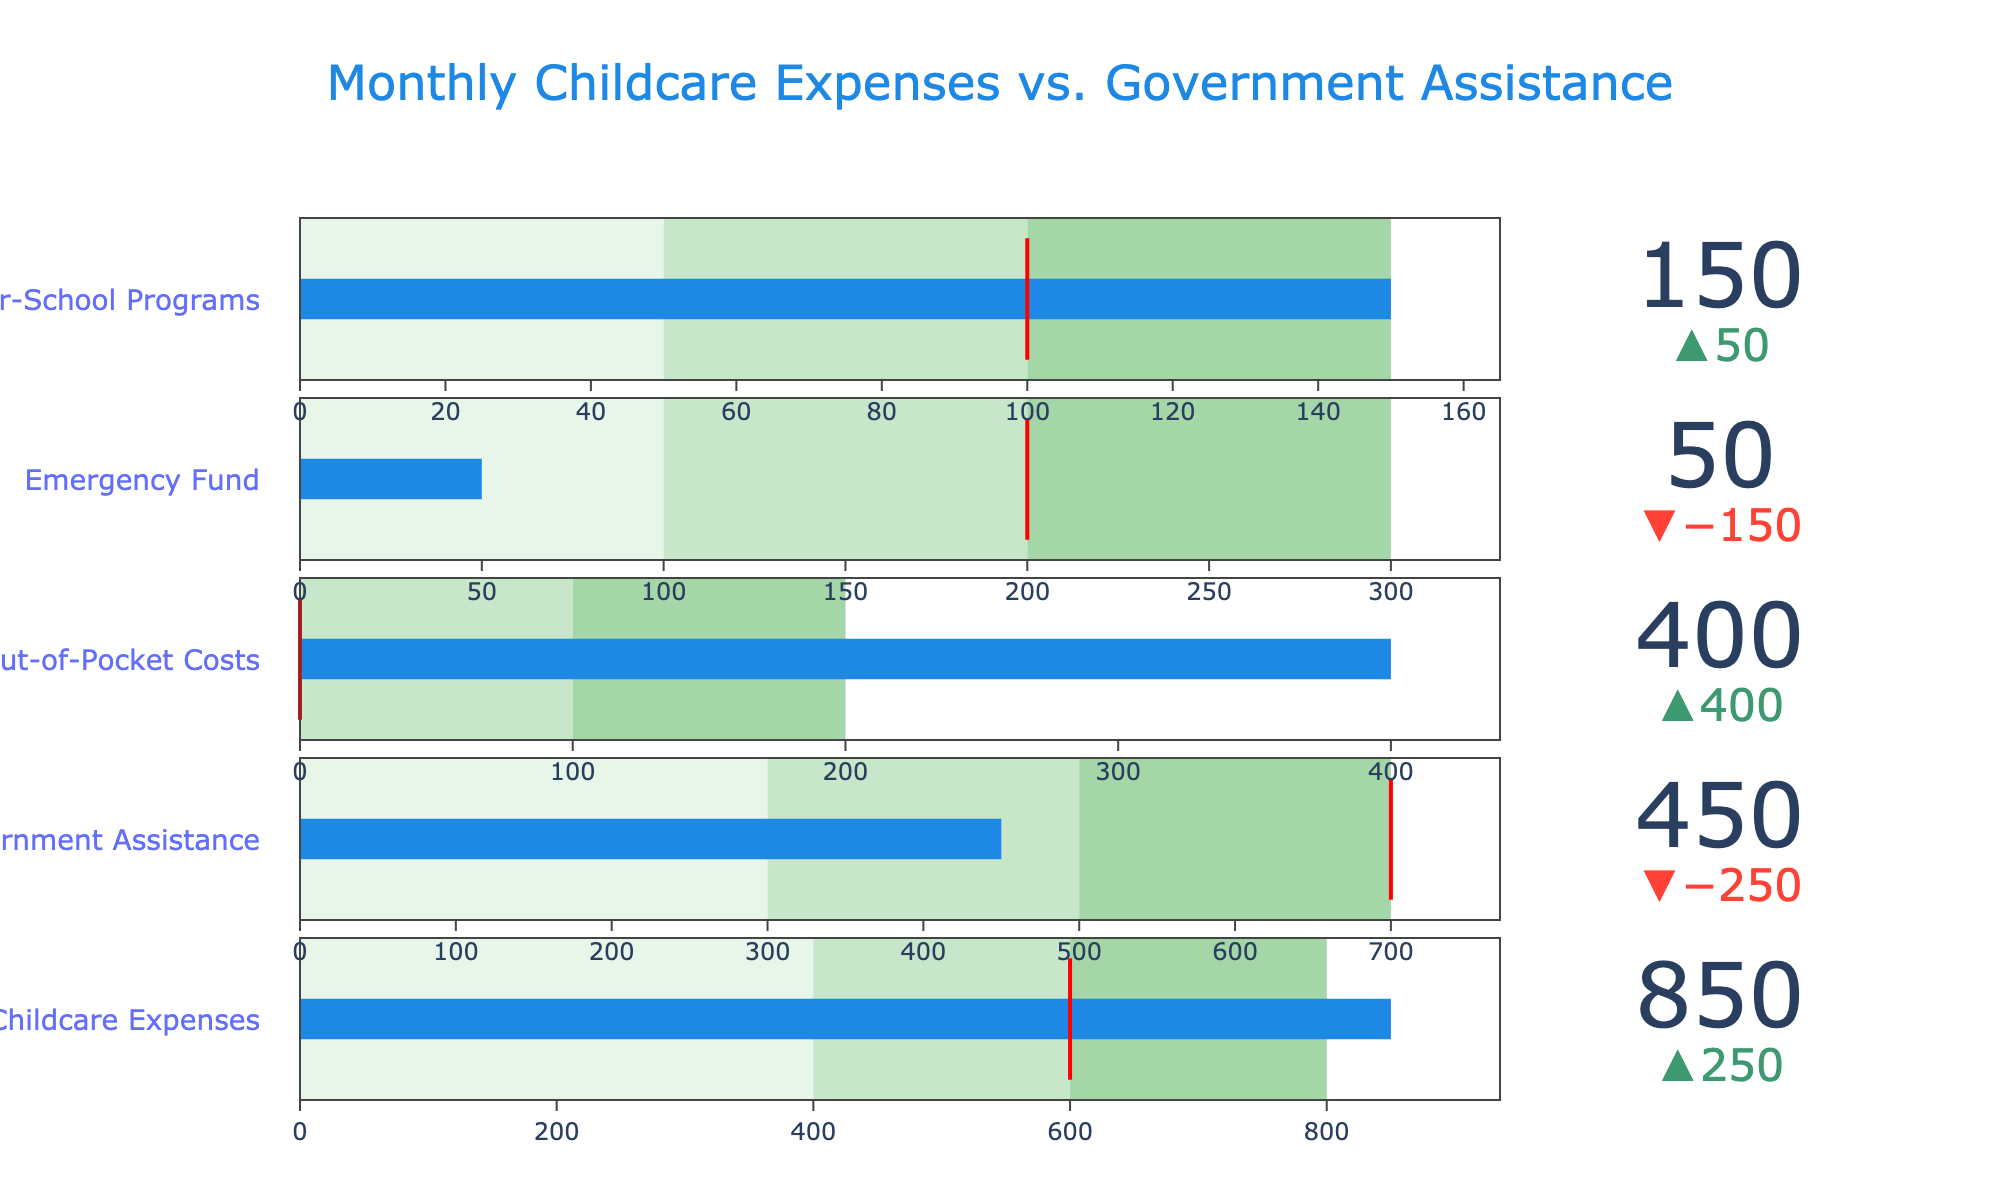What is the title of the figure? The title is prominently displayed at the top of the figure in a large font.
Answer: Monthly Childcare Expenses vs. Government Assistance How much are the actual monthly childcare expenses? The actual monthly childcare expenses value is marked in the bullet chart under the "Childcare Expenses" category.
Answer: 850 What is the target value for government assistance? The target value for government assistance is indicated by the red threshold line in the "Government Assistance" category.
Answer: 700 Which category shows the biggest difference between the actual value and the target value? By comparing the deltas (differences) between the actual and target values across all categories, you can identify the largest difference. The "Emergency Fund" category shows the biggest difference as the actual (50) is much lower than the target (200).
Answer: Emergency Fund In which categories does the actual value exceed the target value? By observing each category, look for cases where the actual value (blue bar) is longer than the threshold line (target value). This occurs in the "Childcare Expenses" and "After-School Programs" categories.
Answer: Childcare Expenses, After-School Programs What is the difference between the actual and target values for the Emergency Fund? Subtract the target value from the actual value for the "Emergency Fund" category: 50 (actual) - 200 (target).
Answer: -150 How much out-of-pocket costs do we have, and how does it compare to its maximum range? The actual out-of-pocket costs are 400. The maximum range value is 200. The actual value exceeds the maximum range by comparing 400 to 200.
Answer: 400, exceeds the range What are the three different range colors in the figure? Each bullet chart includes three color-coded ranges which represent thresholds. The colors seen are light green (#E8F5E9), medium green (#C8E6C9), and dark green (#A5D6A7).
Answer: Light green, medium green, dark green Which category has the smallest actual value? The actual values are indicated by the blue bars. The smallest blue bar is found under the "Emergency Fund" category, which has an actual value of 50.
Answer: Emergency Fund How does the target value for out-of-pocket costs affect the actual expenses? Since the target value for out-of-pocket costs is 0, it implies that any amount spent would exceed the target by the same amount. The actual value is 400 which is exactly 400 more than the target.
Answer: Exceeds by 400 